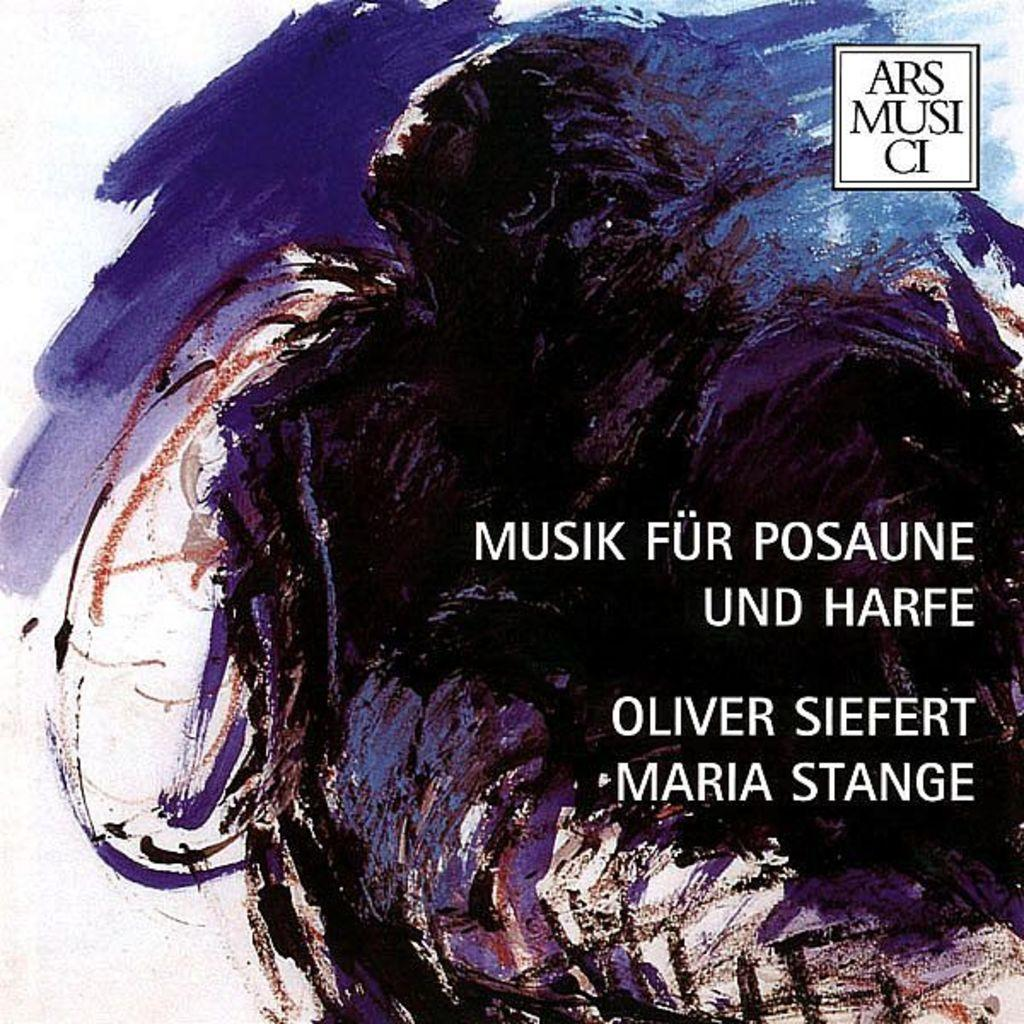What is the main subject of the image? The main subject of the image is a painting. Can you describe any additional elements in the image? Yes, there is text in the image. What is the scent of the painting in the image? Paintings do not have a scent, so this question cannot be answered. 